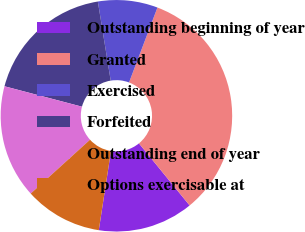Convert chart. <chart><loc_0><loc_0><loc_500><loc_500><pie_chart><fcel>Outstanding beginning of year<fcel>Granted<fcel>Exercised<fcel>Forfeited<fcel>Outstanding end of year<fcel>Options exercisable at<nl><fcel>13.33%<fcel>33.33%<fcel>8.33%<fcel>18.33%<fcel>15.83%<fcel>10.83%<nl></chart> 